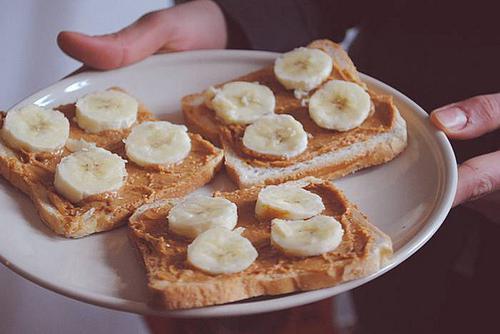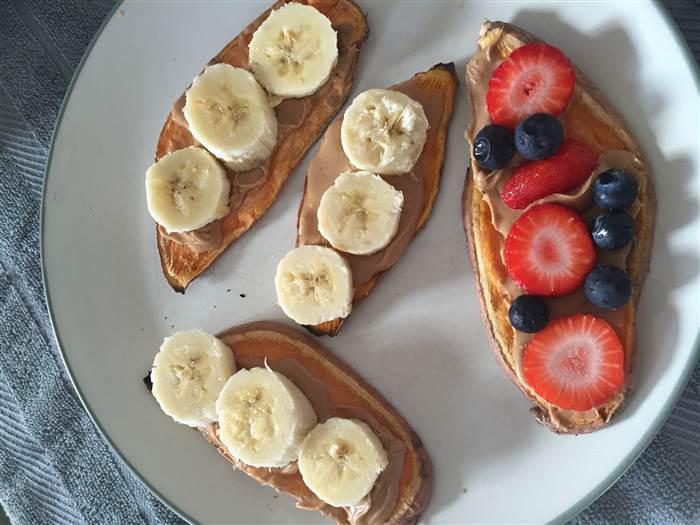The first image is the image on the left, the second image is the image on the right. For the images displayed, is the sentence "Twenty one or fewer banana slices are visible." factually correct? Answer yes or no. Yes. 